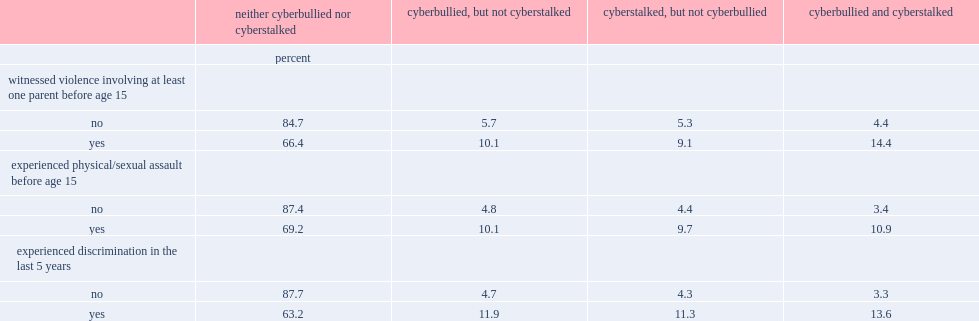What were the percentages of those who had ever witnessed violence involving at least one of their parents when they were under the age of 15 who said they had been a victim of cyberstalking, had been a victim of cyberbullying and experienced both? 9.1 10.1 14.4. What were the percentages of those who experienced an assault in childhood who experienced cyberstalking, cyberbullying, or both? 10.1 9.7 10.9. Among individuals who had been a victim of discrimination in the last five years,which did they most likely to report that they had experienced? Cyberbullied and cyberstalked. 